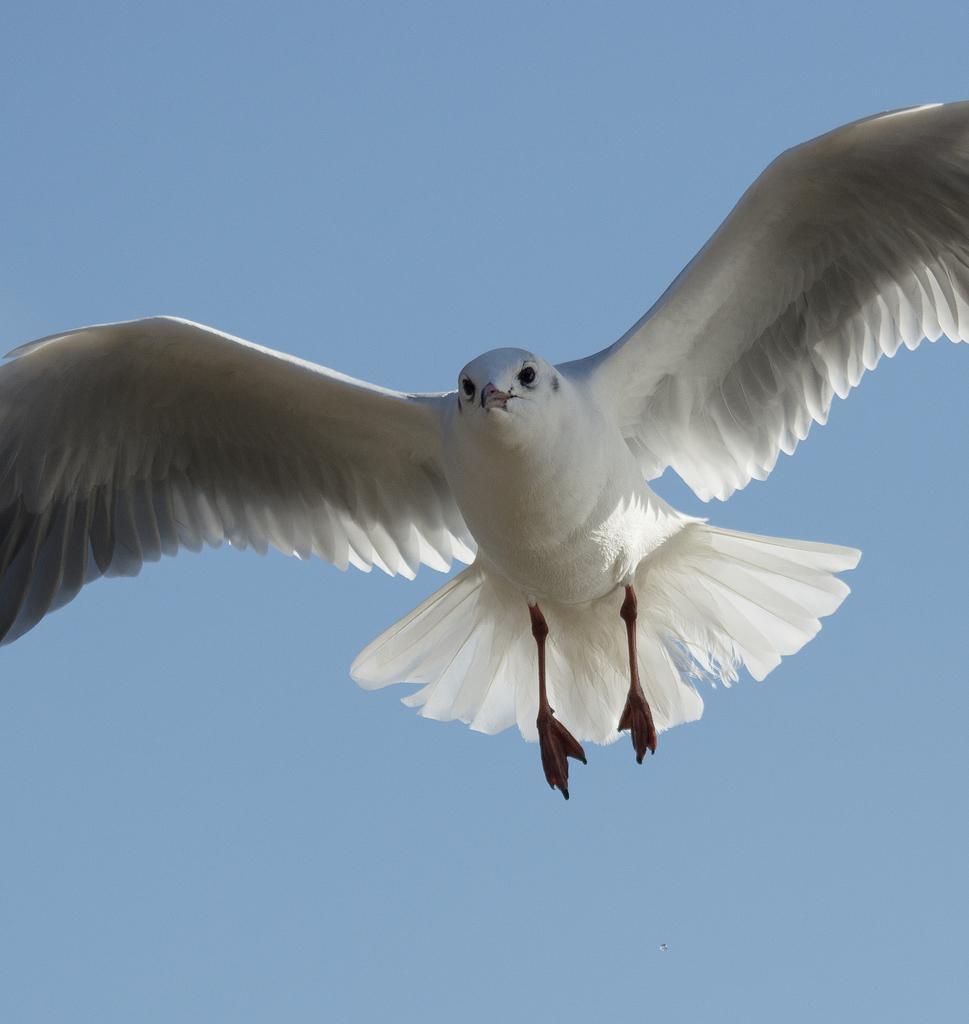How would you summarize this image in a sentence or two? In the center of the image we can see a bird flying in the sky. 